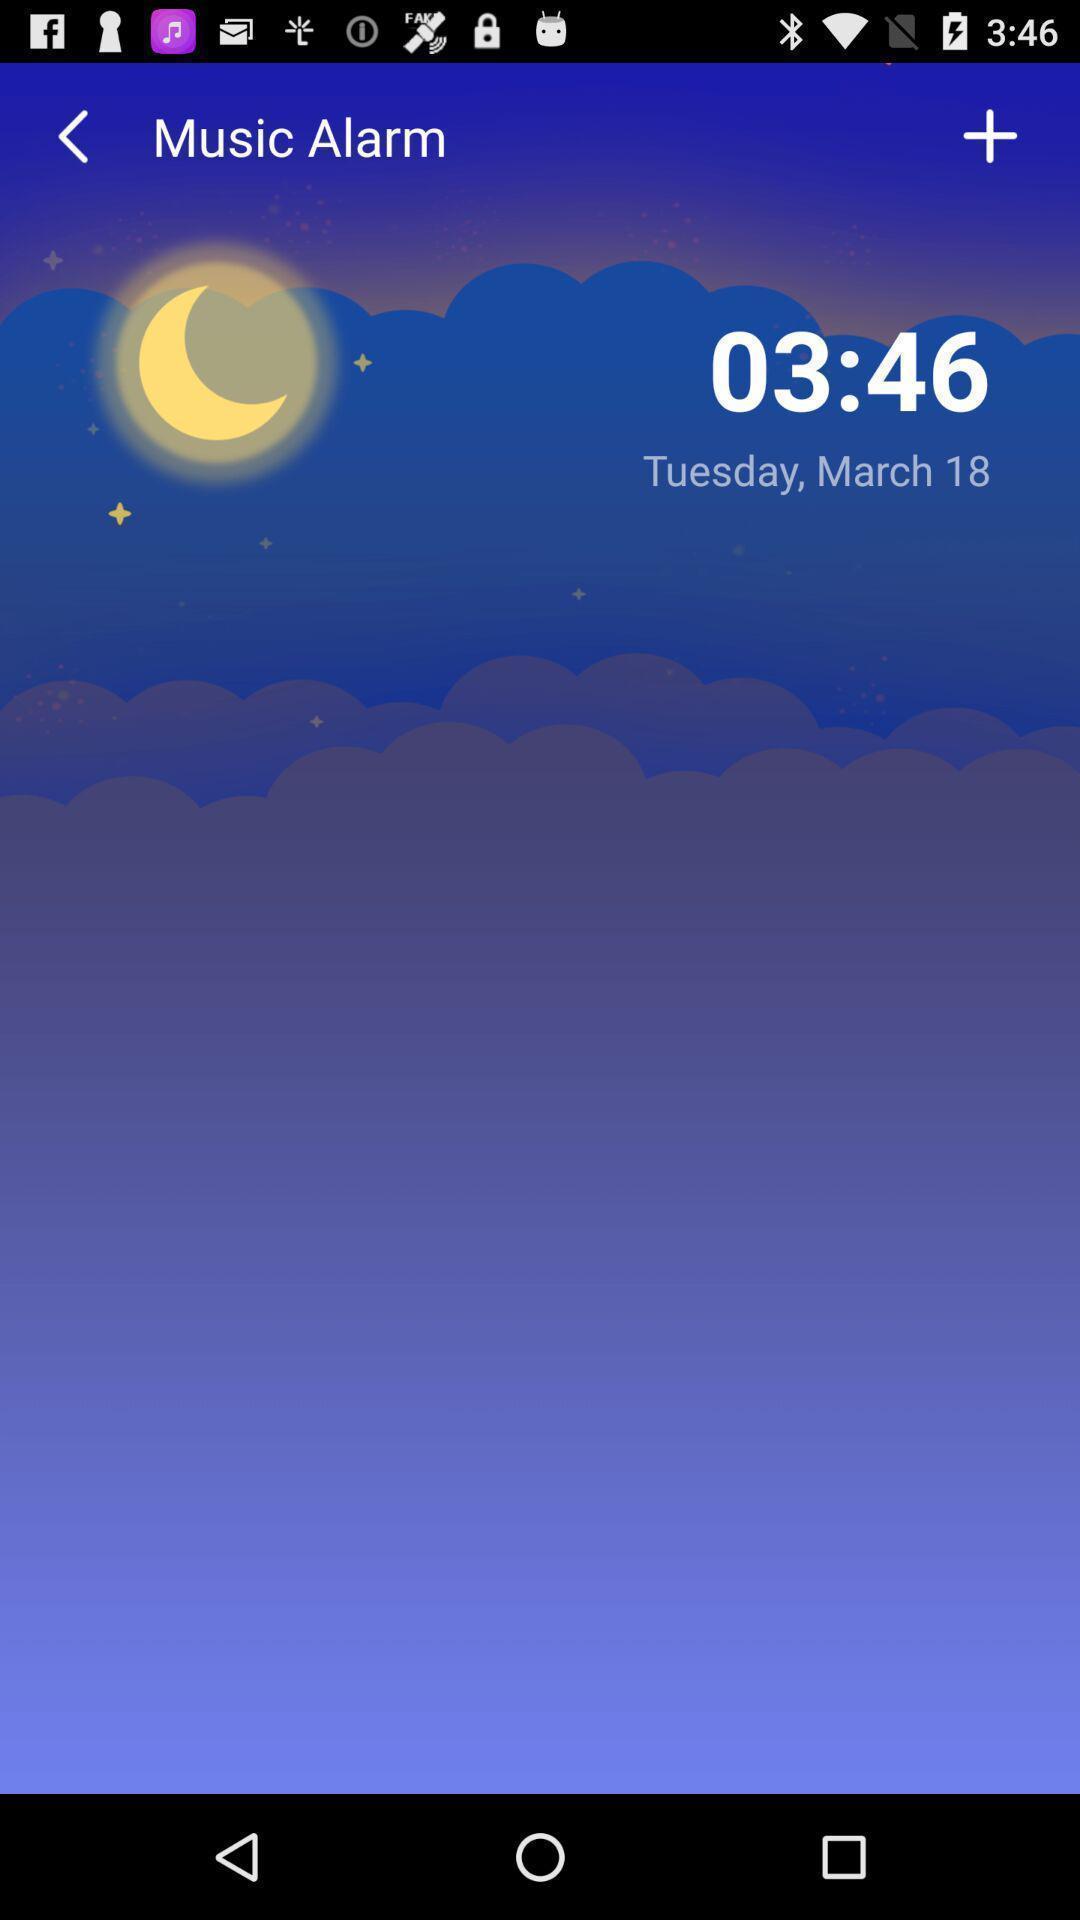What can you discern from this picture? Screen displaying an alarm set for a time. 